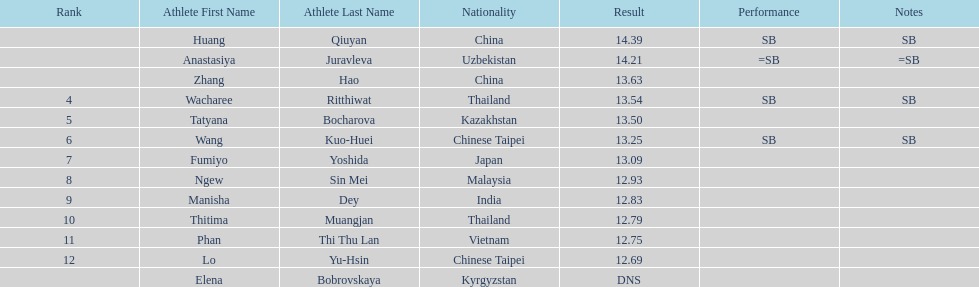Which country had the most competitors ranked in the top three in the event? China. 